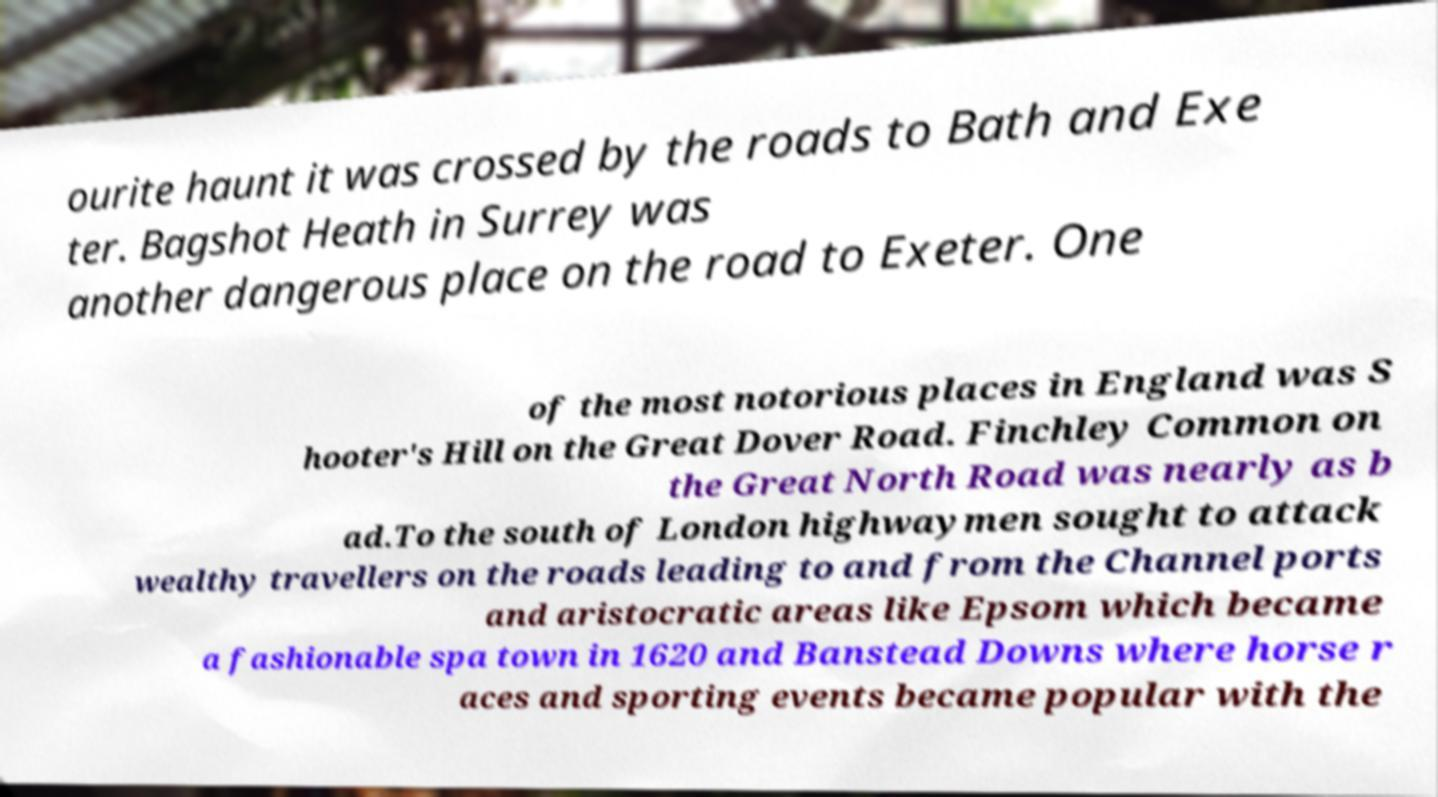Could you extract and type out the text from this image? ourite haunt it was crossed by the roads to Bath and Exe ter. Bagshot Heath in Surrey was another dangerous place on the road to Exeter. One of the most notorious places in England was S hooter's Hill on the Great Dover Road. Finchley Common on the Great North Road was nearly as b ad.To the south of London highwaymen sought to attack wealthy travellers on the roads leading to and from the Channel ports and aristocratic areas like Epsom which became a fashionable spa town in 1620 and Banstead Downs where horse r aces and sporting events became popular with the 